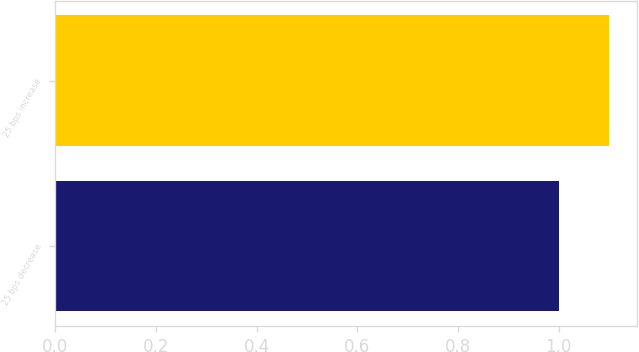Convert chart to OTSL. <chart><loc_0><loc_0><loc_500><loc_500><bar_chart><fcel>25 bps decrease<fcel>25 bps increase<nl><fcel>1<fcel>1.1<nl></chart> 